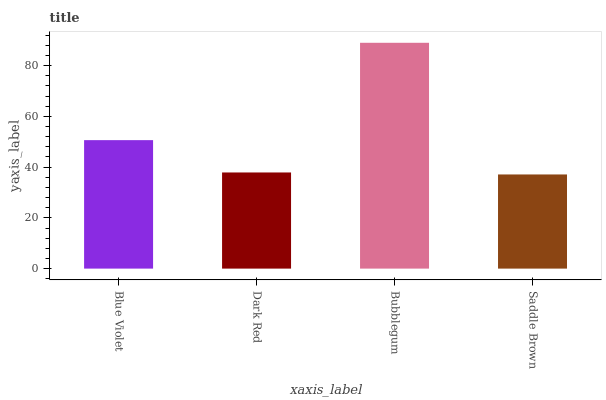Is Bubblegum the maximum?
Answer yes or no. Yes. Is Dark Red the minimum?
Answer yes or no. No. Is Dark Red the maximum?
Answer yes or no. No. Is Blue Violet greater than Dark Red?
Answer yes or no. Yes. Is Dark Red less than Blue Violet?
Answer yes or no. Yes. Is Dark Red greater than Blue Violet?
Answer yes or no. No. Is Blue Violet less than Dark Red?
Answer yes or no. No. Is Blue Violet the high median?
Answer yes or no. Yes. Is Dark Red the low median?
Answer yes or no. Yes. Is Dark Red the high median?
Answer yes or no. No. Is Bubblegum the low median?
Answer yes or no. No. 